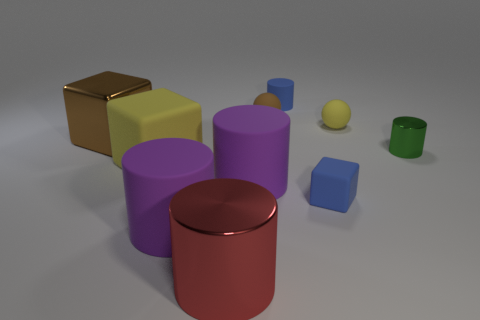What is the material of the brown cube that is in front of the matte cylinder that is behind the purple rubber thing to the right of the red metallic cylinder?
Offer a very short reply. Metal. What number of other objects are there of the same size as the shiny block?
Your answer should be compact. 4. What color is the shiny block?
Offer a very short reply. Brown. How many matte objects are either small cylinders or green objects?
Your answer should be compact. 1. There is a ball that is on the left side of the tiny blue matte thing behind the metallic cylinder that is behind the big yellow rubber thing; what is its size?
Your answer should be very brief. Small. There is a matte object that is in front of the brown sphere and behind the big metal block; how big is it?
Ensure brevity in your answer.  Small. Does the rubber block that is left of the tiny matte cylinder have the same color as the shiny cylinder in front of the green cylinder?
Your answer should be very brief. No. There is a blue cylinder; what number of yellow matte balls are to the left of it?
Provide a short and direct response. 0. There is a blue thing in front of the big shiny thing that is behind the tiny green object; are there any rubber blocks that are right of it?
Provide a short and direct response. No. How many balls have the same size as the blue cube?
Provide a short and direct response. 2. 